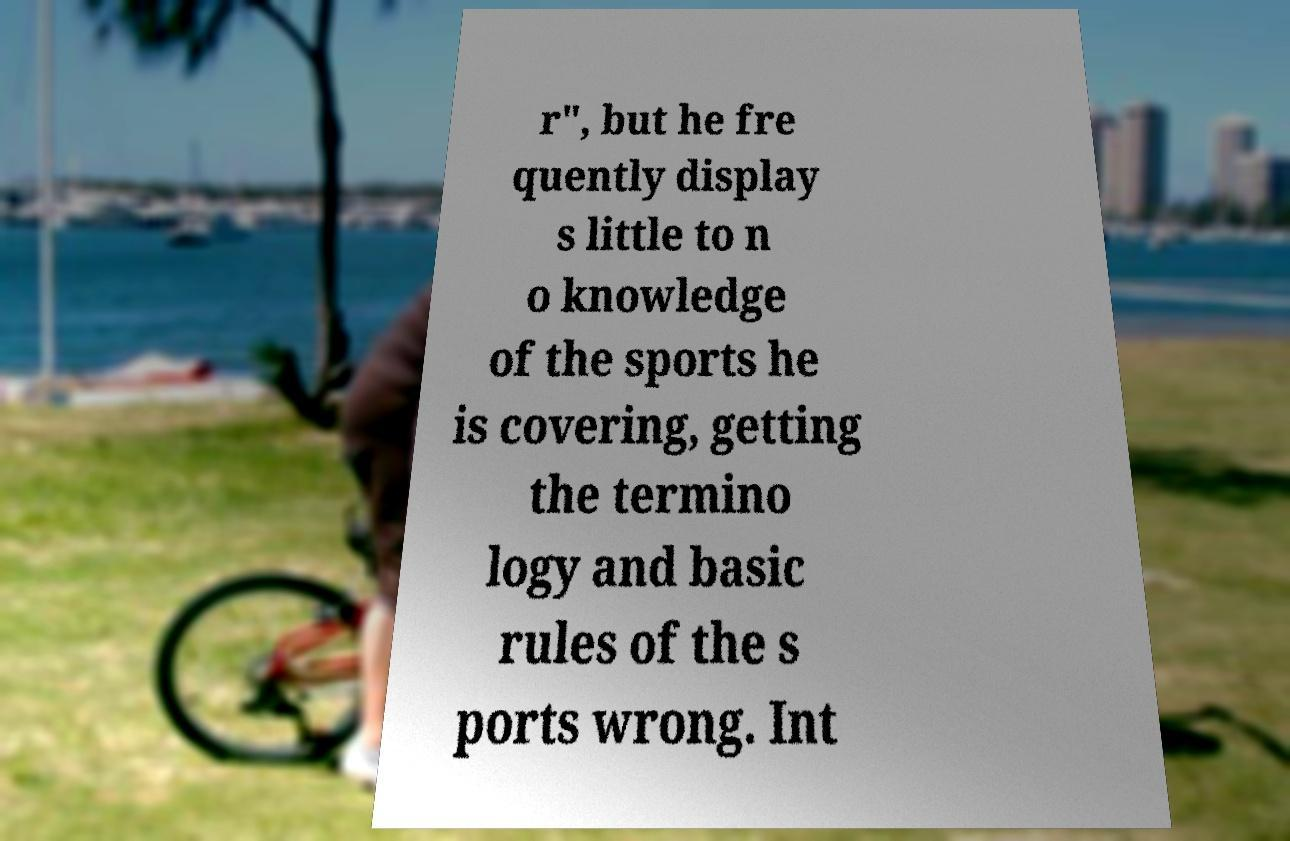Please identify and transcribe the text found in this image. r", but he fre quently display s little to n o knowledge of the sports he is covering, getting the termino logy and basic rules of the s ports wrong. Int 